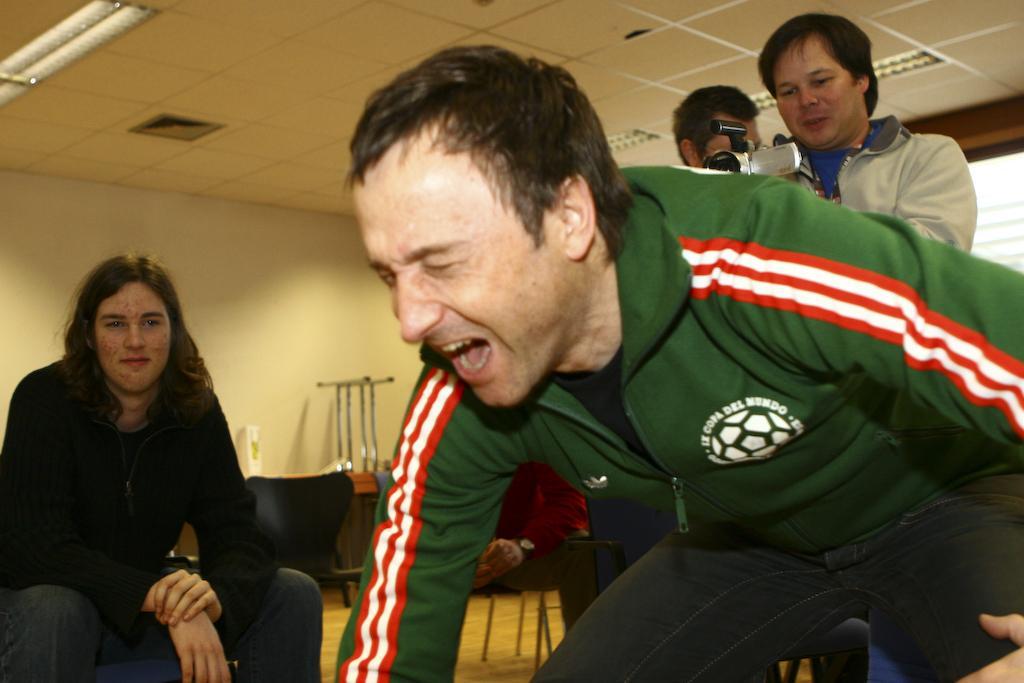Describe this image in one or two sentences. In the center of the image a man is bending and shouting. On the left side of the image a person is sitting on a chair. In the middle of the image we can see two persons are standing and a man is holding a camera. In the background of the image we can see the tables, chairs, wall, window. At the top of the image we can see the roof and lights. At the bottom of the image we can see the floor. 